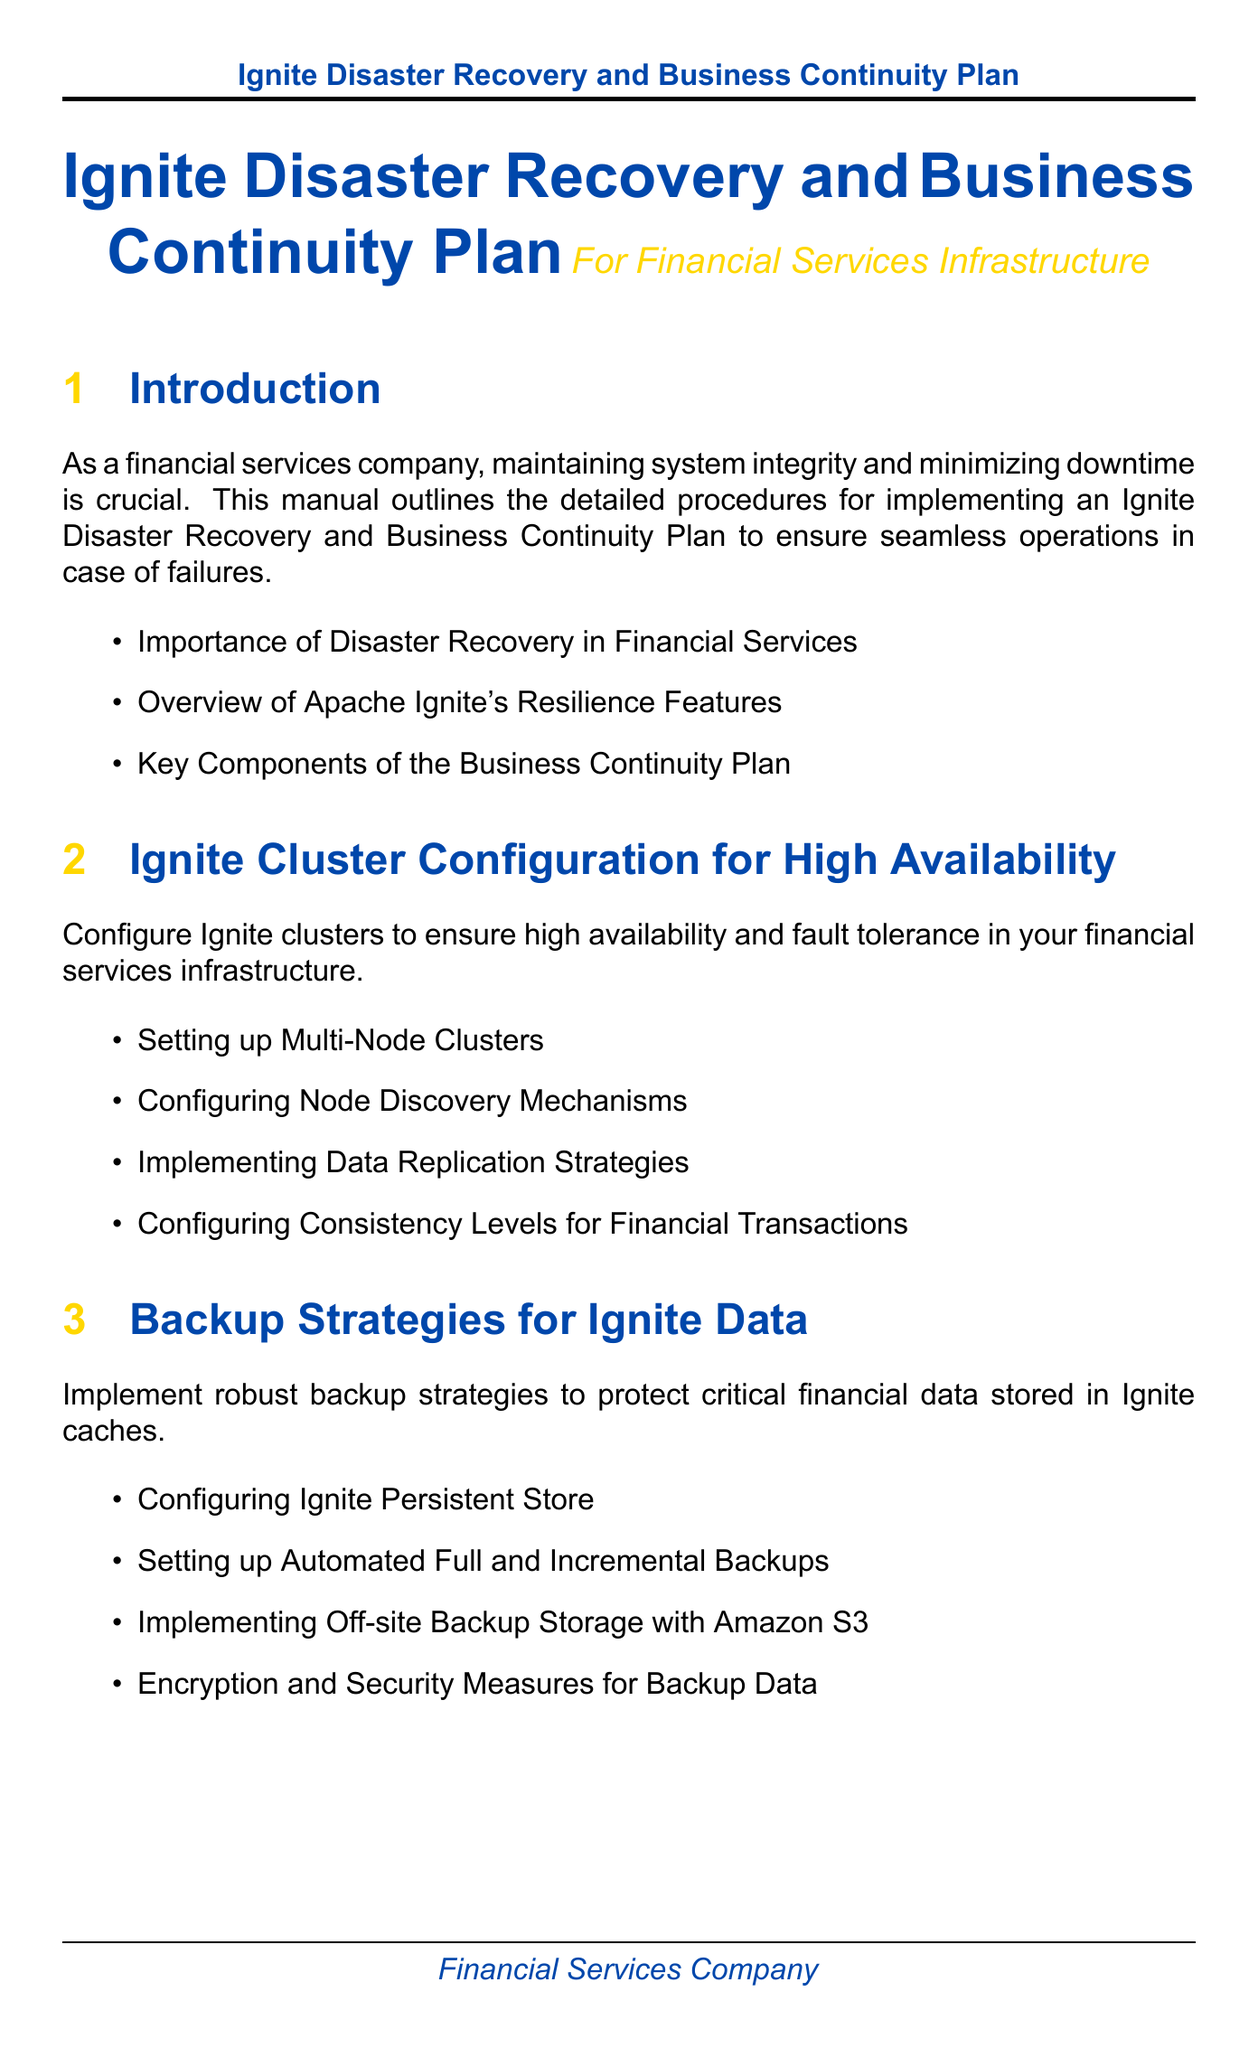What is the title of the manual? The title of the manual is presented at the beginning, emphasizing its purpose.
Answer: Ignite Disaster Recovery and Business Continuity Plan What section outlines backup strategies? The section that covers backup strategies is explicitly labeled in the manual.
Answer: Backup Strategies for Ignite Data How often should disaster recovery drills be scheduled? This information is specified within the testing procedures to ensure effectiveness.
Answer: Quarterly What does RTO stand for? The term is mentioned in the context of defining objectives related to recovery time.
Answer: Recovery Time Objectives What color is used for section headings? The document specifies a color scheme used for section titles.
Answer: Main color How many subsections are in the "Failover Configurations and Procedures"? This number is determined by counting the listed subsections under that section.
Answer: Four Which tool is mentioned for log aggregation? The tool is specifically identified in the monitoring section addressing logging.
Answer: ELK Stack What are the implications of FINRA and SEC? This context is discussed regarding the compliance requirements in the manual.
Answer: Compliance What should be documented after testing recovery drills? This detail ensures continuous improvement and the effectiveness of the plan.
Answer: Test Results 